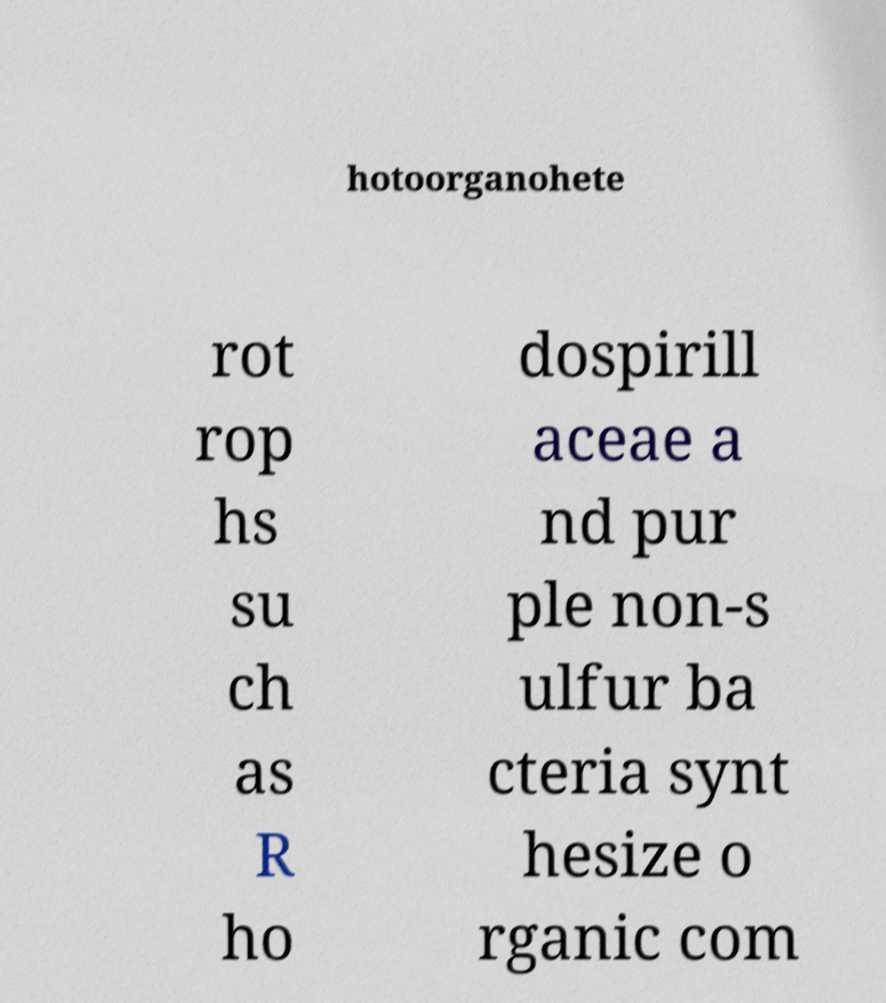Can you read and provide the text displayed in the image?This photo seems to have some interesting text. Can you extract and type it out for me? hotoorganohete rot rop hs su ch as R ho dospirill aceae a nd pur ple non-s ulfur ba cteria synt hesize o rganic com 